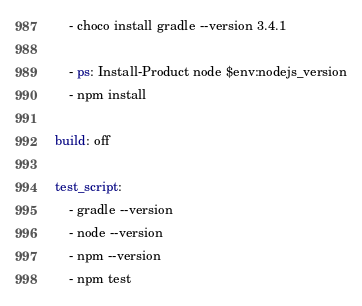<code> <loc_0><loc_0><loc_500><loc_500><_YAML_>
    - choco install gradle --version 3.4.1

    - ps: Install-Product node $env:nodejs_version
    - npm install

build: off

test_script:
    - gradle --version
    - node --version
    - npm --version
    - npm test
</code> 